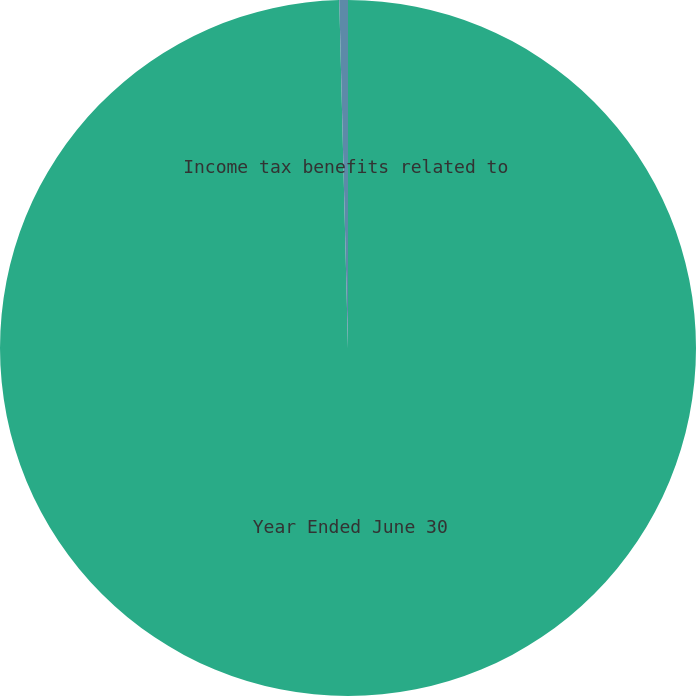<chart> <loc_0><loc_0><loc_500><loc_500><pie_chart><fcel>Year Ended June 30<fcel>Income tax benefits related to<nl><fcel>99.6%<fcel>0.4%<nl></chart> 